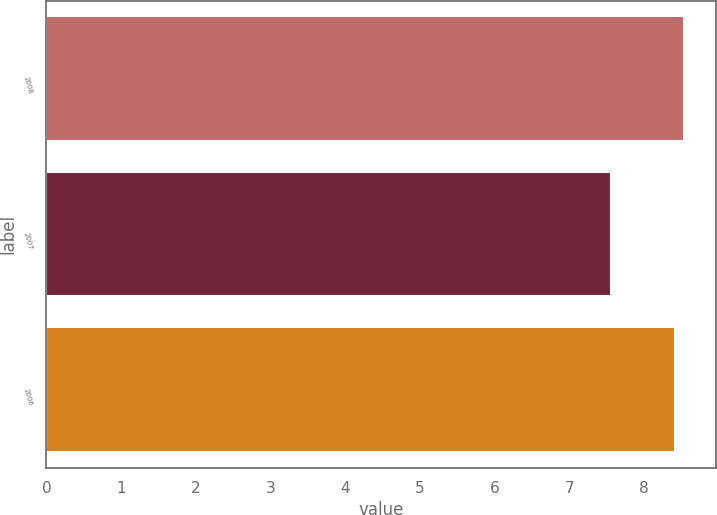Convert chart. <chart><loc_0><loc_0><loc_500><loc_500><bar_chart><fcel>2008<fcel>2007<fcel>2006<nl><fcel>8.54<fcel>7.56<fcel>8.42<nl></chart> 